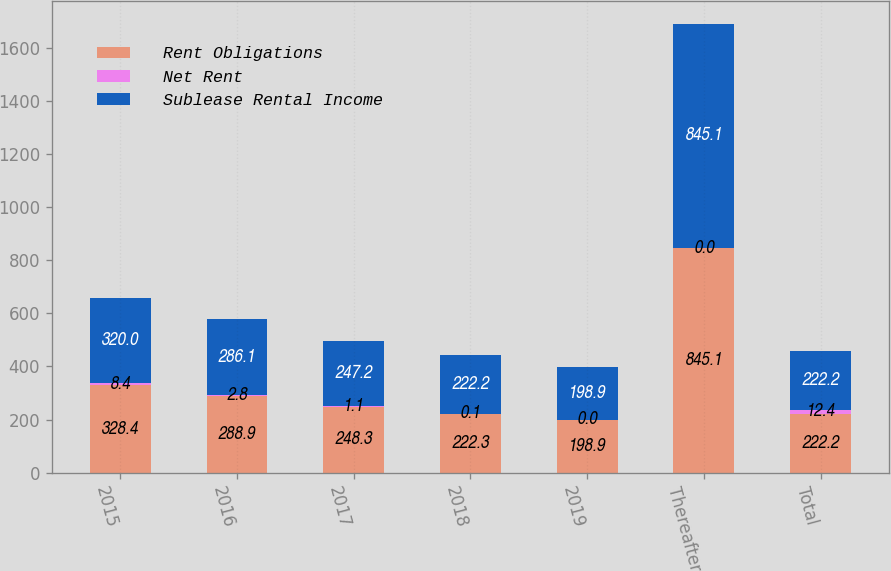<chart> <loc_0><loc_0><loc_500><loc_500><stacked_bar_chart><ecel><fcel>2015<fcel>2016<fcel>2017<fcel>2018<fcel>2019<fcel>Thereafter<fcel>Total<nl><fcel>Rent Obligations<fcel>328.4<fcel>288.9<fcel>248.3<fcel>222.3<fcel>198.9<fcel>845.1<fcel>222.2<nl><fcel>Net Rent<fcel>8.4<fcel>2.8<fcel>1.1<fcel>0.1<fcel>0<fcel>0<fcel>12.4<nl><fcel>Sublease Rental Income<fcel>320<fcel>286.1<fcel>247.2<fcel>222.2<fcel>198.9<fcel>845.1<fcel>222.2<nl></chart> 